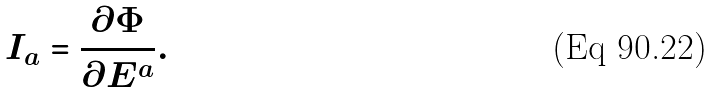<formula> <loc_0><loc_0><loc_500><loc_500>I _ { a } = \frac { \partial \Phi } { \partial E ^ { a } } .</formula> 